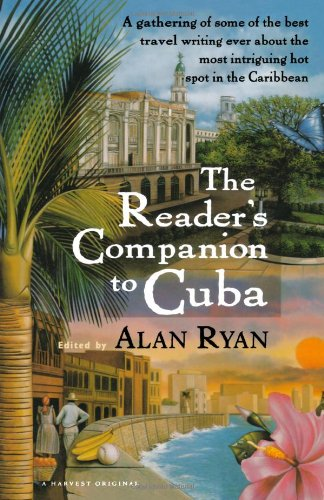What is the title of this book? The title displayed prominently on the cover of the book is 'The Reader's Companion to Cuba.' 